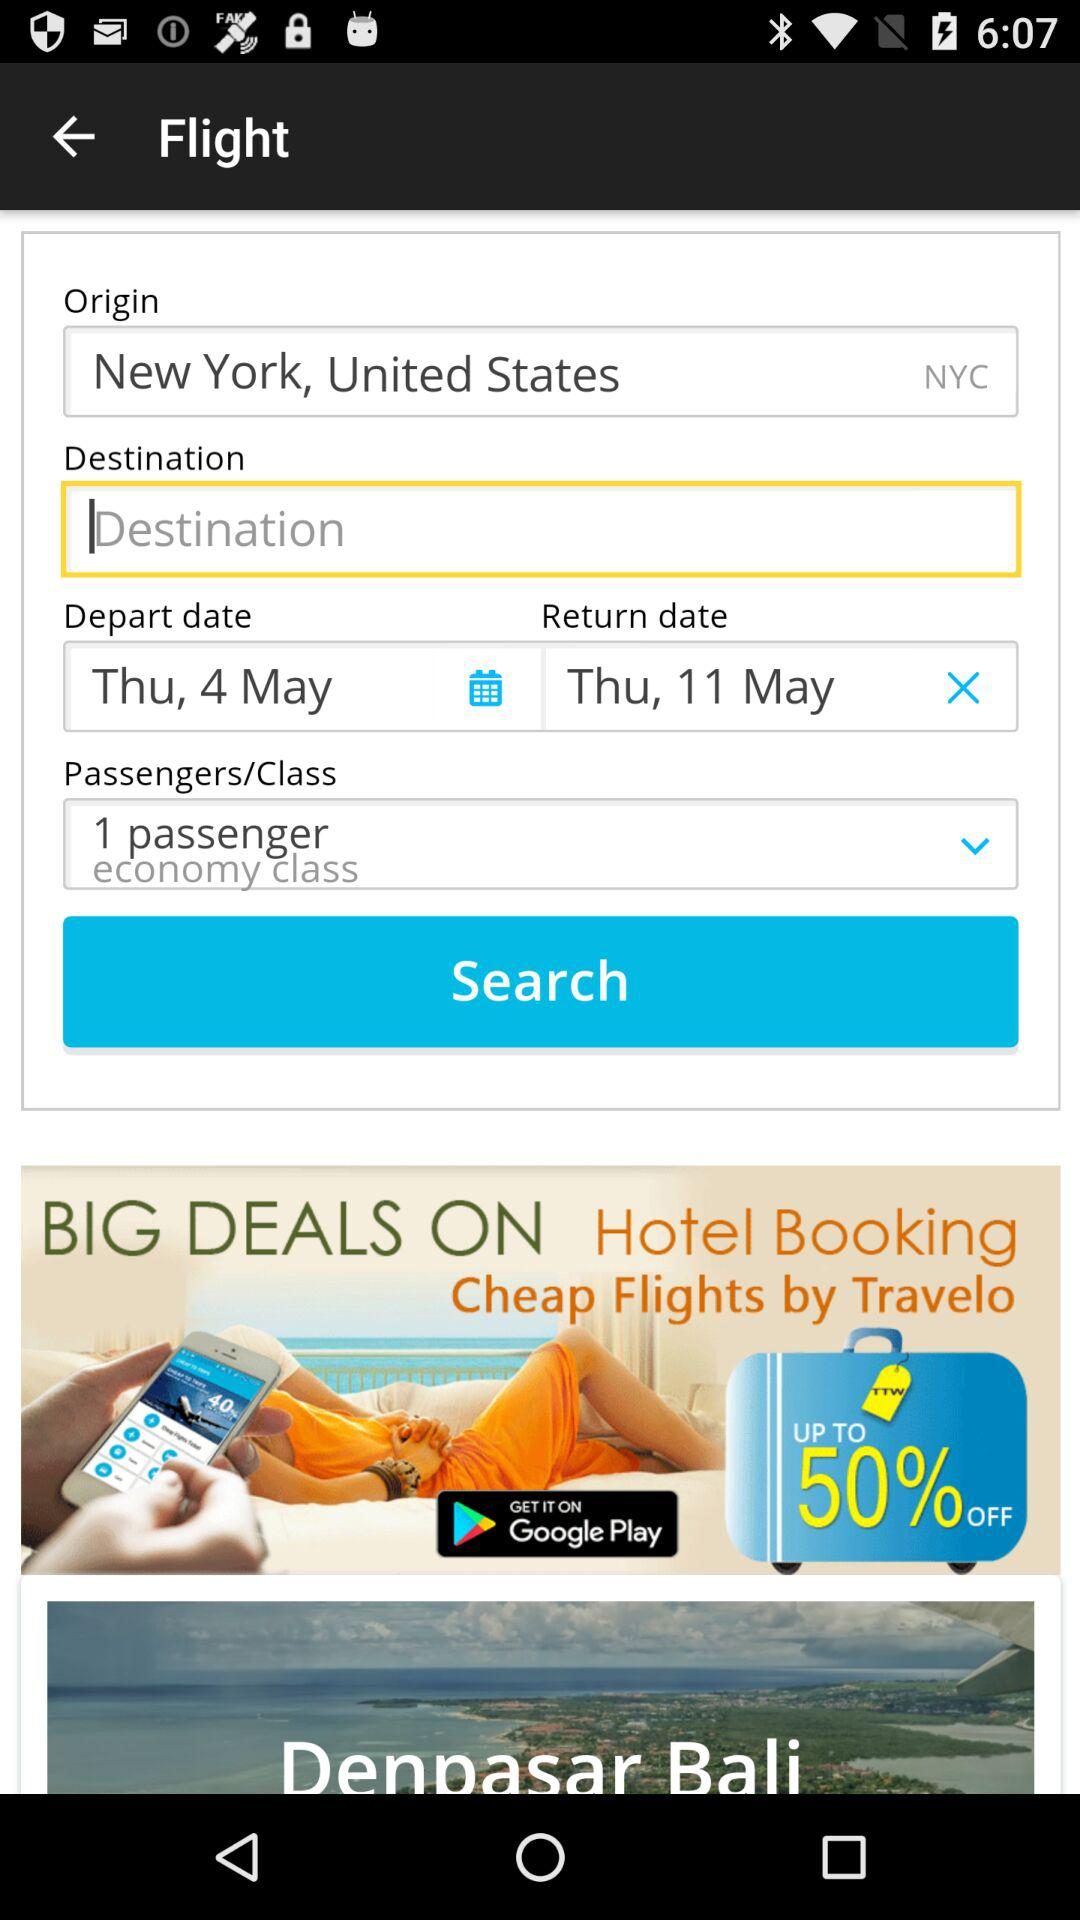How many passengers are there in this booking? 1 